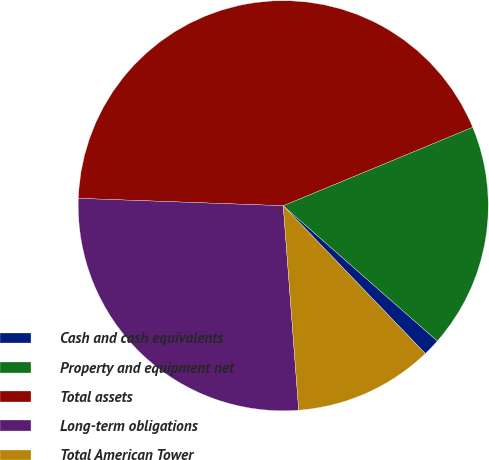<chart> <loc_0><loc_0><loc_500><loc_500><pie_chart><fcel>Cash and cash equivalents<fcel>Property and equipment net<fcel>Total assets<fcel>Long-term obligations<fcel>Total American Tower<nl><fcel>1.35%<fcel>17.72%<fcel>43.17%<fcel>26.77%<fcel>10.98%<nl></chart> 